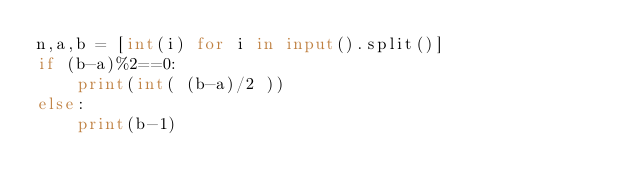Convert code to text. <code><loc_0><loc_0><loc_500><loc_500><_Python_>n,a,b = [int(i) for i in input().split()]
if (b-a)%2==0:
    print(int( (b-a)/2 ))
else:
    print(b-1)</code> 